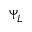<formula> <loc_0><loc_0><loc_500><loc_500>\Psi _ { L }</formula> 